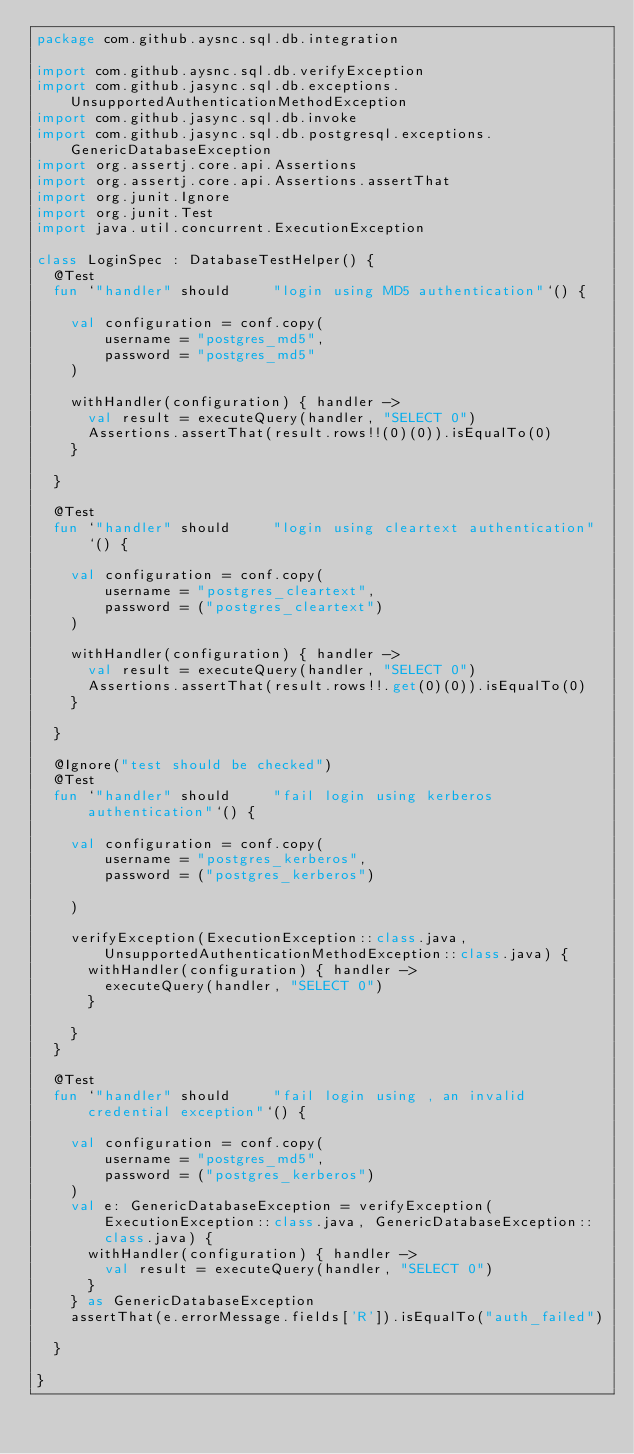<code> <loc_0><loc_0><loc_500><loc_500><_Kotlin_>package com.github.aysnc.sql.db.integration

import com.github.aysnc.sql.db.verifyException
import com.github.jasync.sql.db.exceptions.UnsupportedAuthenticationMethodException
import com.github.jasync.sql.db.invoke
import com.github.jasync.sql.db.postgresql.exceptions.GenericDatabaseException
import org.assertj.core.api.Assertions
import org.assertj.core.api.Assertions.assertThat
import org.junit.Ignore
import org.junit.Test
import java.util.concurrent.ExecutionException

class LoginSpec : DatabaseTestHelper() {
  @Test
  fun `"handler" should     "login using MD5 authentication"`() {

    val configuration = conf.copy(
        username = "postgres_md5",
        password = "postgres_md5"
    )

    withHandler(configuration) { handler ->
      val result = executeQuery(handler, "SELECT 0")
      Assertions.assertThat(result.rows!!(0)(0)).isEqualTo(0)
    }

  }

  @Test
  fun `"handler" should     "login using cleartext authentication"`() {

    val configuration = conf.copy(
        username = "postgres_cleartext",
        password = ("postgres_cleartext")
    )

    withHandler(configuration) { handler ->
      val result = executeQuery(handler, "SELECT 0")
      Assertions.assertThat(result.rows!!.get(0)(0)).isEqualTo(0)
    }

  }

  @Ignore("test should be checked")
  @Test
  fun `"handler" should     "fail login using kerberos authentication"`() {

    val configuration = conf.copy(
        username = "postgres_kerberos",
        password = ("postgres_kerberos")

    )

    verifyException(ExecutionException::class.java, UnsupportedAuthenticationMethodException::class.java) {
      withHandler(configuration) { handler ->
        executeQuery(handler, "SELECT 0")
      }

    }
  }

  @Test
  fun `"handler" should     "fail login using , an invalid credential exception"`() {

    val configuration = conf.copy(
        username = "postgres_md5",
        password = ("postgres_kerberos")
    )
    val e: GenericDatabaseException = verifyException(ExecutionException::class.java, GenericDatabaseException::class.java) {
      withHandler(configuration) { handler ->
        val result = executeQuery(handler, "SELECT 0")
      }
    } as GenericDatabaseException
    assertThat(e.errorMessage.fields['R']).isEqualTo("auth_failed")

  }

}

</code> 